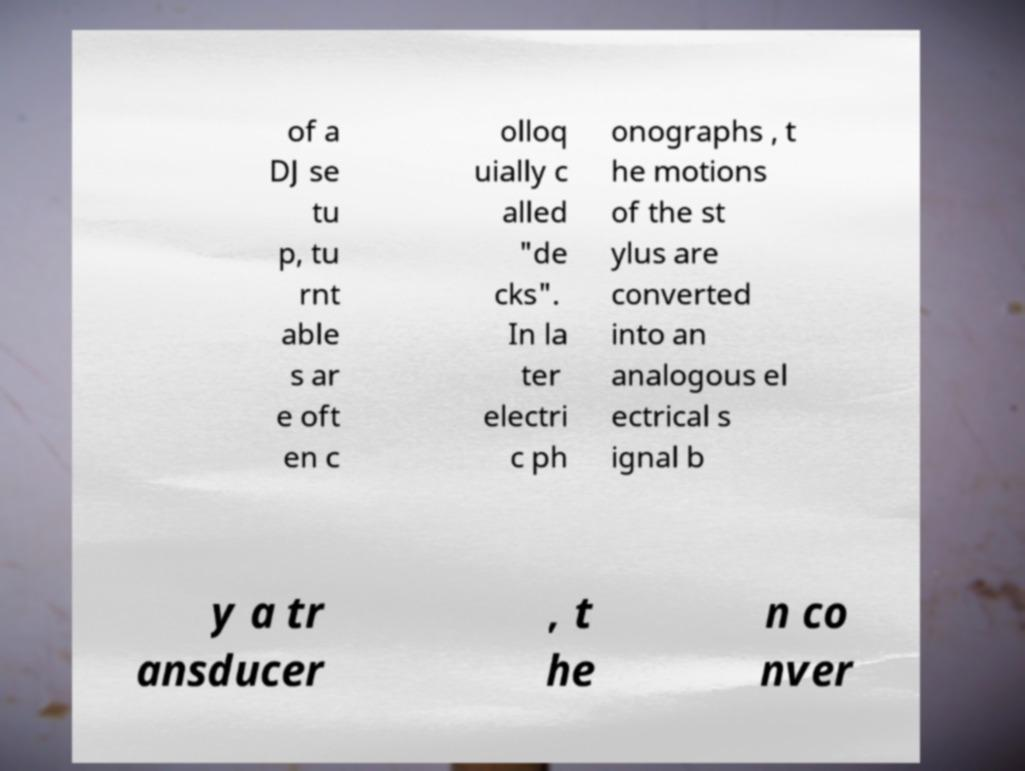What messages or text are displayed in this image? I need them in a readable, typed format. of a DJ se tu p, tu rnt able s ar e oft en c olloq uially c alled "de cks". In la ter electri c ph onographs , t he motions of the st ylus are converted into an analogous el ectrical s ignal b y a tr ansducer , t he n co nver 